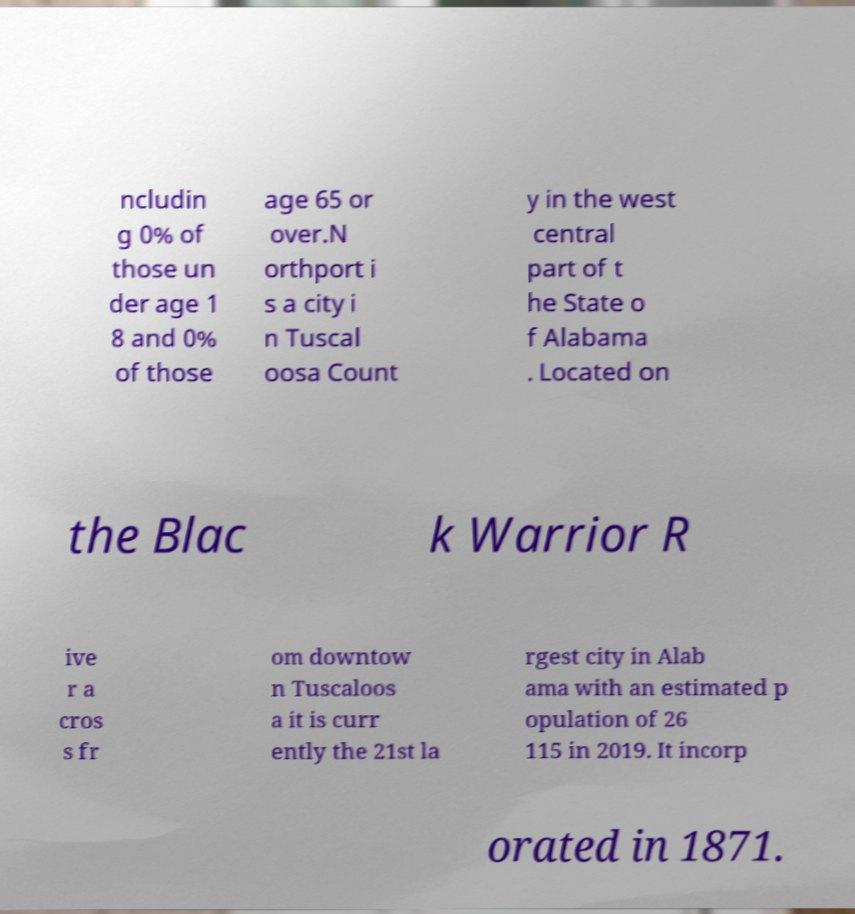Could you assist in decoding the text presented in this image and type it out clearly? ncludin g 0% of those un der age 1 8 and 0% of those age 65 or over.N orthport i s a city i n Tuscal oosa Count y in the west central part of t he State o f Alabama . Located on the Blac k Warrior R ive r a cros s fr om downtow n Tuscaloos a it is curr ently the 21st la rgest city in Alab ama with an estimated p opulation of 26 115 in 2019. It incorp orated in 1871. 